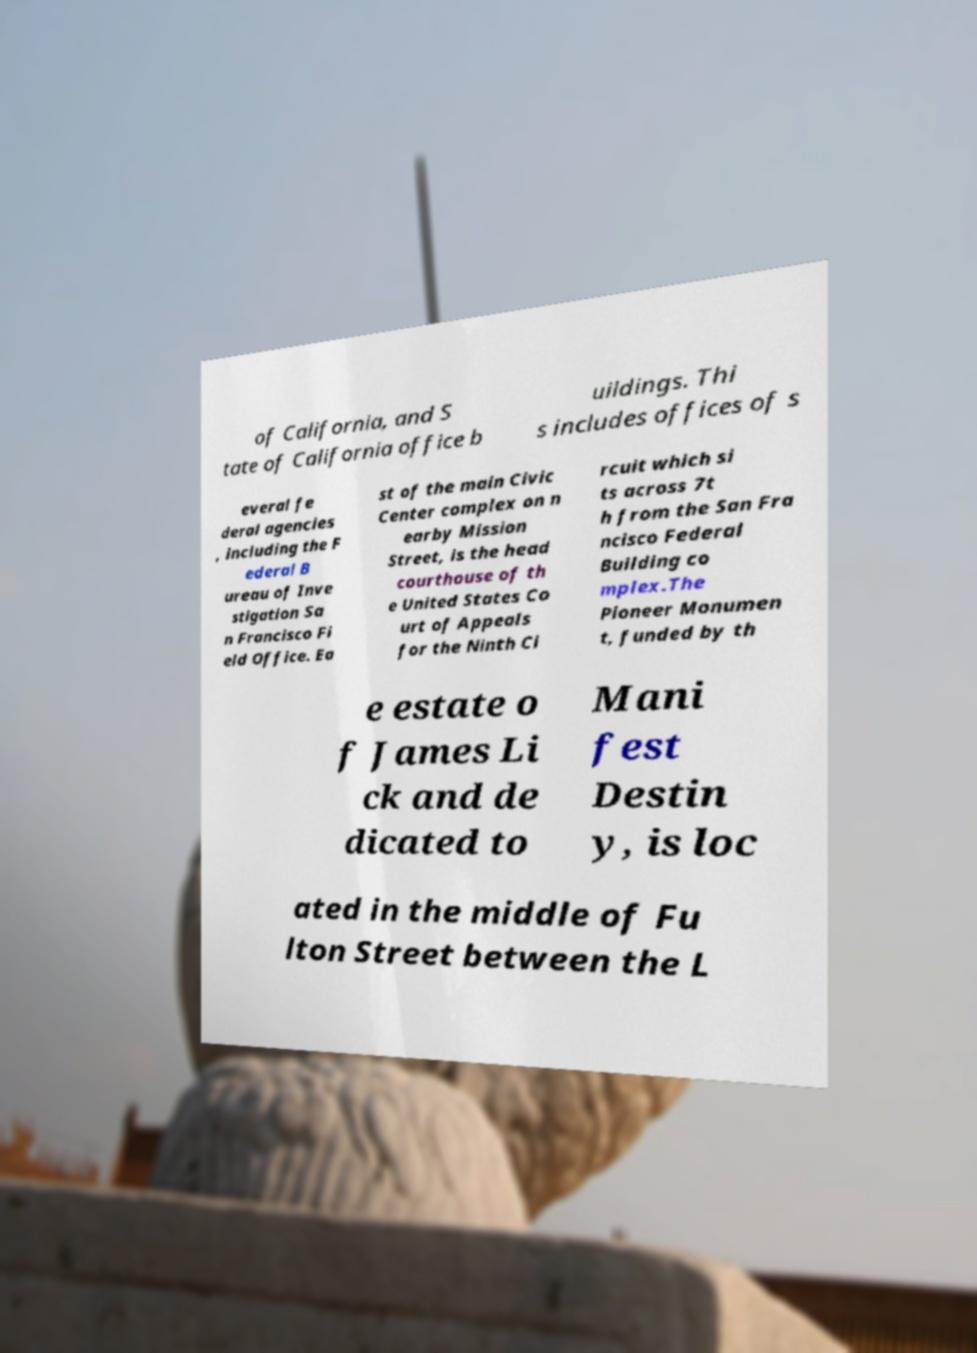What messages or text are displayed in this image? I need them in a readable, typed format. of California, and S tate of California office b uildings. Thi s includes offices of s everal fe deral agencies , including the F ederal B ureau of Inve stigation Sa n Francisco Fi eld Office. Ea st of the main Civic Center complex on n earby Mission Street, is the head courthouse of th e United States Co urt of Appeals for the Ninth Ci rcuit which si ts across 7t h from the San Fra ncisco Federal Building co mplex.The Pioneer Monumen t, funded by th e estate o f James Li ck and de dicated to Mani fest Destin y, is loc ated in the middle of Fu lton Street between the L 